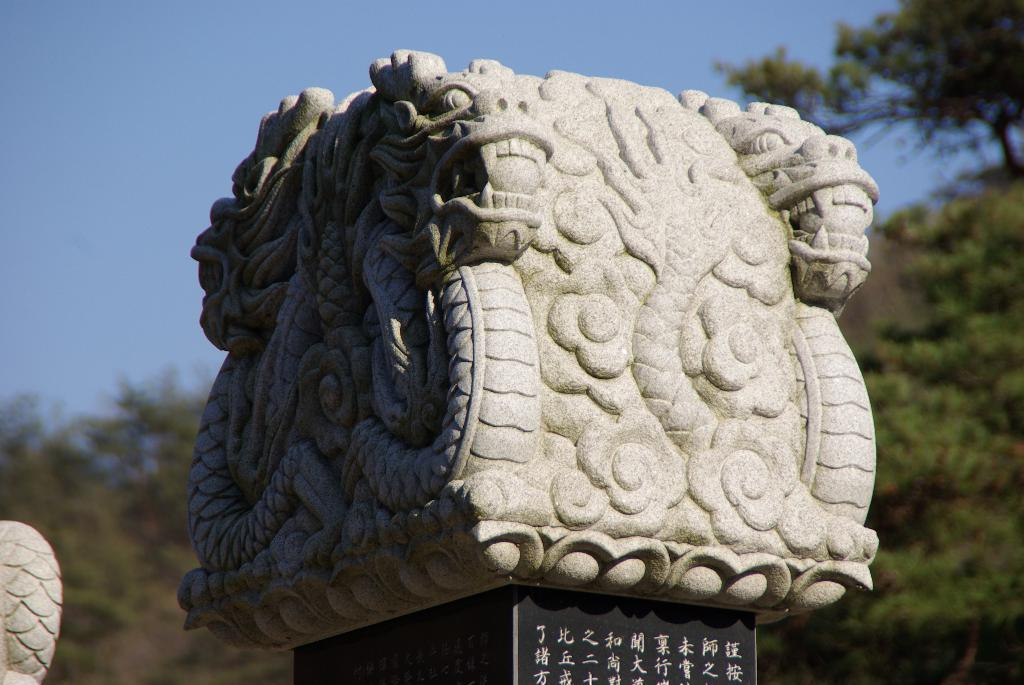What is the main object in the image? There is a carving stone in the image. What can be seen in the background of the image? There are trees in the background of the image. How many cubs are playing with the carving stone in the image? There are no cubs present in the image; it only features a carving stone and trees in the background. What type of snail can be seen crawling on the carving stone in the image? There is no snail present on the carving stone in the image. 